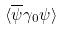<formula> <loc_0><loc_0><loc_500><loc_500>\langle \overline { \psi } \gamma _ { 0 } \psi \rangle</formula> 